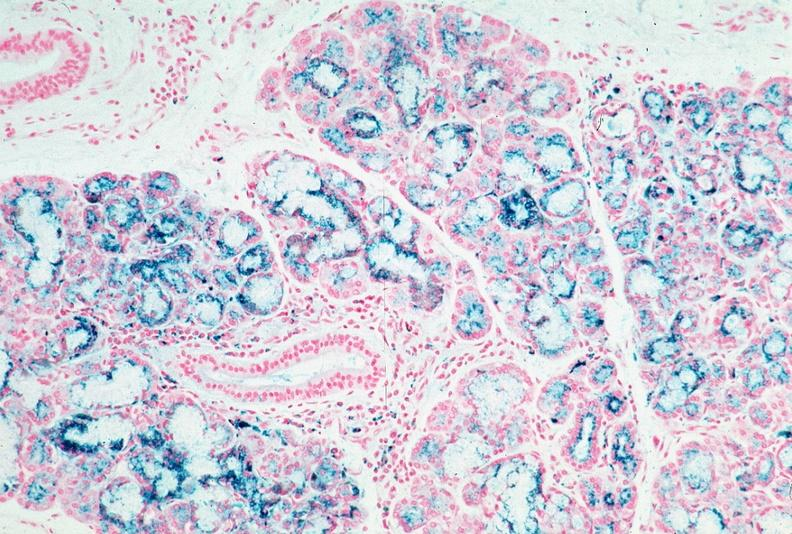does this image show pancreas, hemochromatosis, prussian blue?
Answer the question using a single word or phrase. Yes 